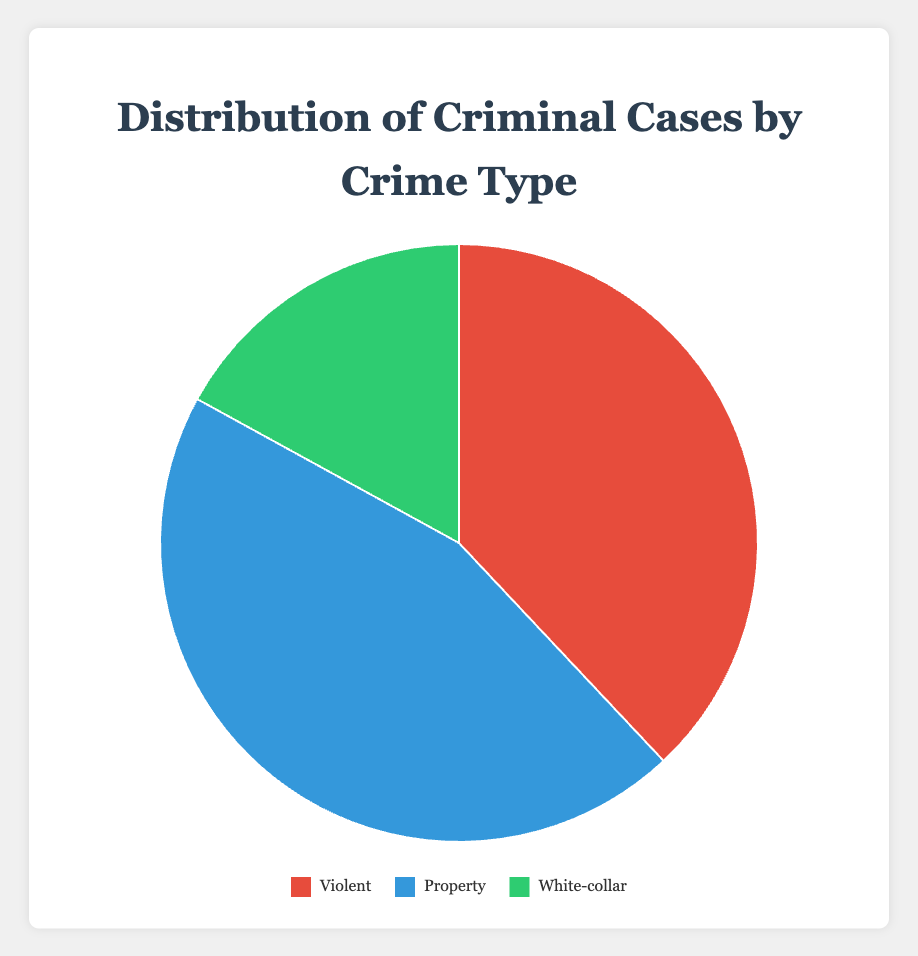Which crime type has the highest percentage of cases? By looking at the segments of the pie chart, we can see the largest segment represents Property crimes, which is 45%.
Answer: Property What is the combined percentage of Violent and White-collar crimes? To find the combined percentage, we add the percentages of Violent (38%) and White-collar (17%) crimes: 38% + 17% = 55%.
Answer: 55% How much larger is the percentage of Property crimes compared to White-collar crimes? To find how much larger Property crimes are, we subtract the percentage of White-collar crimes (17%) from the percentage of Property crimes (45%): 45% - 17% = 28%.
Answer: 28% If the chart's colors are red, blue, and green, which color represents the smallest crime type percentage? The smallest segment in the pie chart represents the White-collar crimes at 17%. As stated, the color order is probably red for Violent, blue for Property, and green for White-Collar. Thus, green represents the smallest percentage.
Answer: Green Which crime type percentage is closer to half of the total cases? We know that Property crimes constitute 45% of the total cases, which is closest to half of the total (50%).
Answer: Property What is the average percentage of all three crime types? To calculate the average, we add the percentages and divide by the number of crime types: (38% + 45% + 17%) / 3 ≈ 33.33%.
Answer: 33.33% Observing the chart, which crime type uses the color blue? The pie chart's largest segment uses blue, representing Property crimes with 45%.
Answer: Property Compare the percentage of Violent crimes to Property crimes. Which is greater and by how much? Property crimes (45%) compared to Violent crimes (38%) are greater by the difference 45% - 38% = 7%.
Answer: Property, 7% If the chart was presented in black and white, how would you identify each crime type based on segment size? The largest segment represents Property (45%), the second-largest is Violent (38%), and the smallest is White-collar (17%).
Answer: Property, Violent, White-collar 